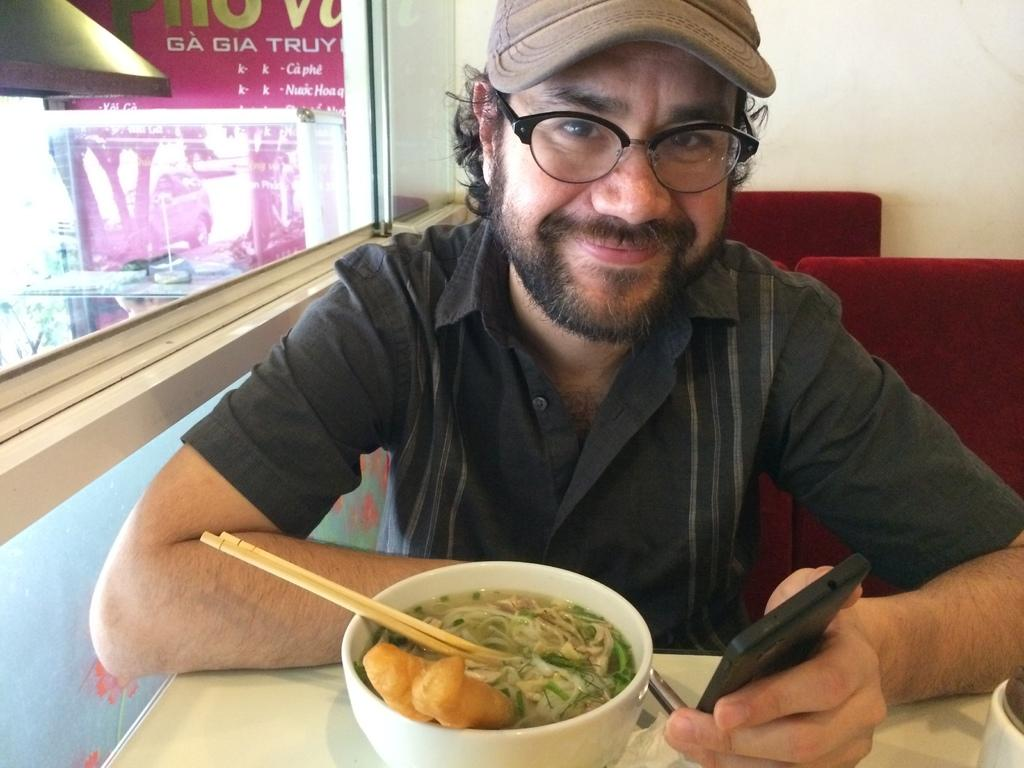What is the person in the image doing? The person is sitting on a chair in the image. What expression does the person have? The person is smiling. What object is the person holding in their hands? The person is holding a mobile in their hands. What is located in front of the person? There is a table in front of the person. What can be found on the table? There are food items on the table. What type of container is visible in the image? There is a glass in the image. What time of day is it in the image? The time of day cannot be determined from the image, as there are no clues to indicate whether it is day or night. Is there a baby present in the image? No, there is no baby present in the image. Can you see an airport in the image? No, there is no airport visible in the image. 